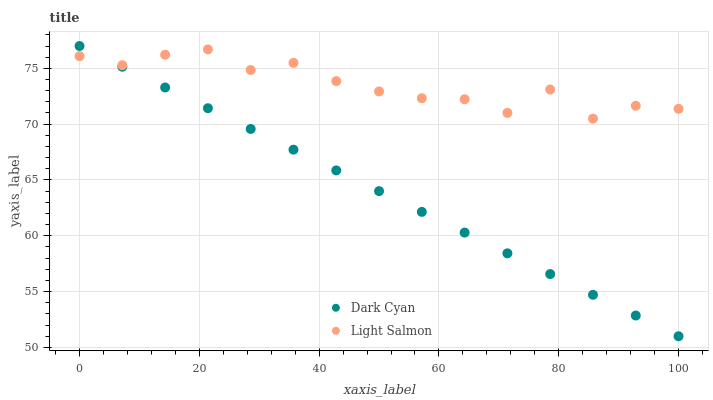Does Dark Cyan have the minimum area under the curve?
Answer yes or no. Yes. Does Light Salmon have the maximum area under the curve?
Answer yes or no. Yes. Does Light Salmon have the minimum area under the curve?
Answer yes or no. No. Is Dark Cyan the smoothest?
Answer yes or no. Yes. Is Light Salmon the roughest?
Answer yes or no. Yes. Is Light Salmon the smoothest?
Answer yes or no. No. Does Dark Cyan have the lowest value?
Answer yes or no. Yes. Does Light Salmon have the lowest value?
Answer yes or no. No. Does Dark Cyan have the highest value?
Answer yes or no. Yes. Does Light Salmon have the highest value?
Answer yes or no. No. Does Dark Cyan intersect Light Salmon?
Answer yes or no. Yes. Is Dark Cyan less than Light Salmon?
Answer yes or no. No. Is Dark Cyan greater than Light Salmon?
Answer yes or no. No. 